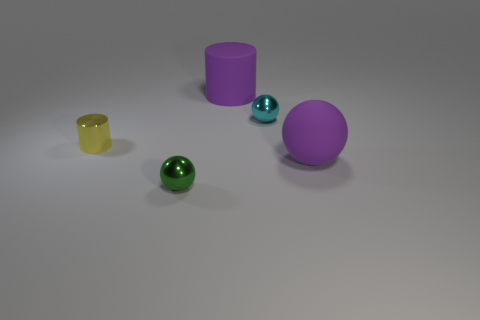What number of large rubber objects are the same color as the large matte ball?
Your answer should be compact. 1. How many matte things are both on the right side of the matte cylinder and on the left side of the big purple ball?
Provide a short and direct response. 0. There is a object that is the same size as the rubber cylinder; what shape is it?
Offer a very short reply. Sphere. The cyan metal sphere is what size?
Keep it short and to the point. Small. There is a green thing that is in front of the small shiny thing right of the small green object that is in front of the purple cylinder; what is its material?
Provide a succinct answer. Metal. There is a large object that is made of the same material as the big purple sphere; what is its color?
Offer a very short reply. Purple. What number of small yellow objects are right of the large thing in front of the small ball behind the tiny yellow metallic cylinder?
Ensure brevity in your answer.  0. There is a big sphere that is the same color as the big cylinder; what is its material?
Keep it short and to the point. Rubber. What number of objects are either large things that are to the right of the matte cylinder or small brown rubber blocks?
Your answer should be compact. 1. There is a large object on the right side of the rubber cylinder; is its color the same as the big rubber cylinder?
Offer a very short reply. Yes. 